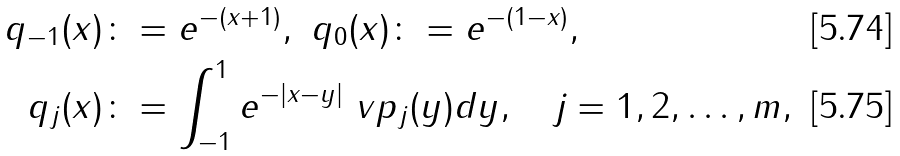<formula> <loc_0><loc_0><loc_500><loc_500>q _ { - 1 } ( x ) & \colon = e ^ { - ( x + 1 ) } , \ q _ { 0 } ( x ) \colon = e ^ { - ( 1 - x ) } , \\ q _ { j } ( x ) & \colon = \int _ { - 1 } ^ { 1 } e ^ { - | x - y | } \ v p _ { j } ( y ) d y , \quad j = 1 , 2 , \hdots , m ,</formula> 